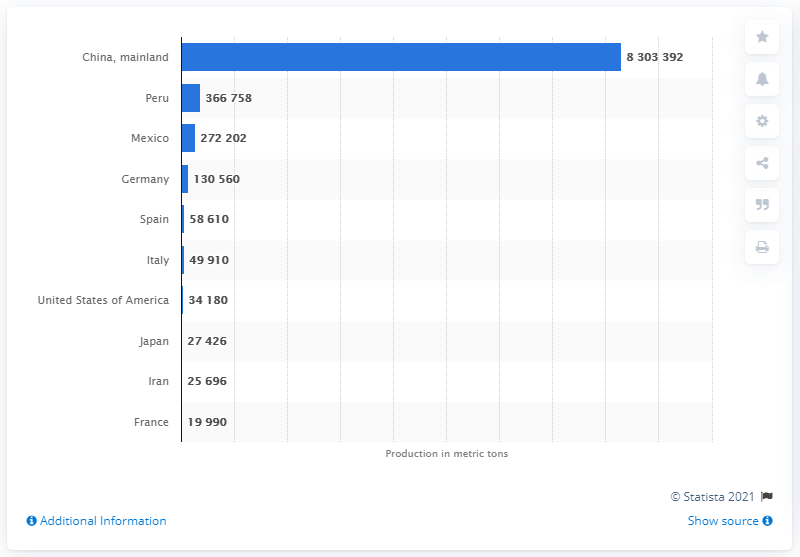Specify some key components in this picture. In 2019, China produced a total of 830,339.2 metric tons of asparagus. 